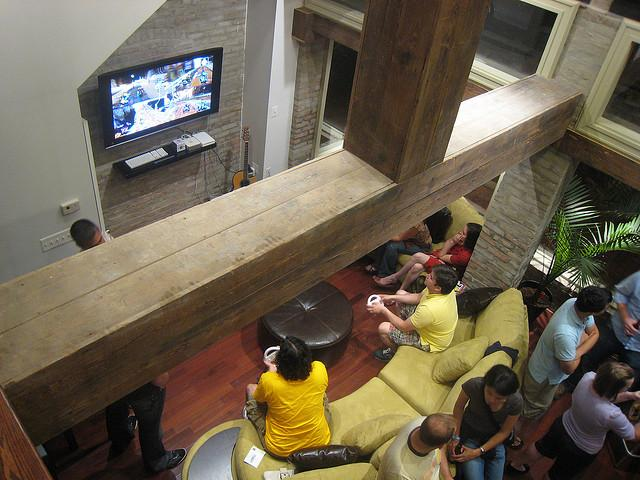The people sitting on the couch are competing in what on the television? Please explain your reasoning. mario kart. They play mario kart. 